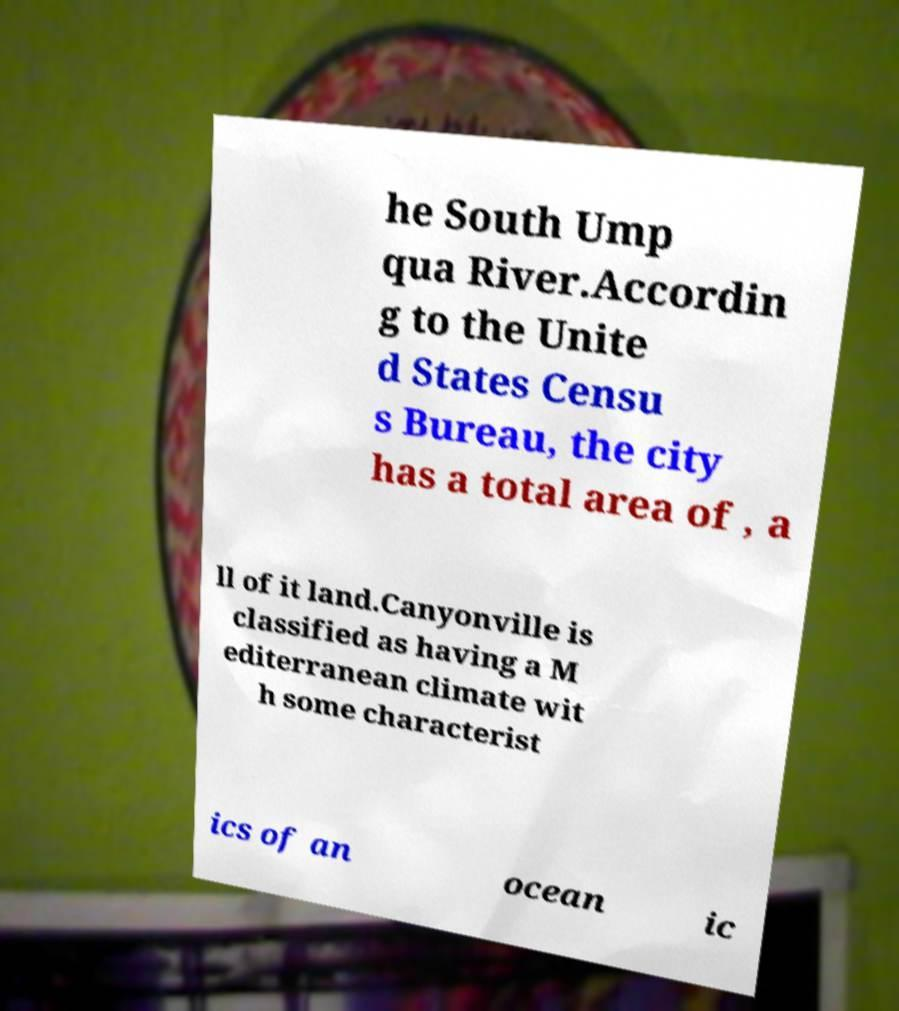Please identify and transcribe the text found in this image. he South Ump qua River.Accordin g to the Unite d States Censu s Bureau, the city has a total area of , a ll of it land.Canyonville is classified as having a M editerranean climate wit h some characterist ics of an ocean ic 